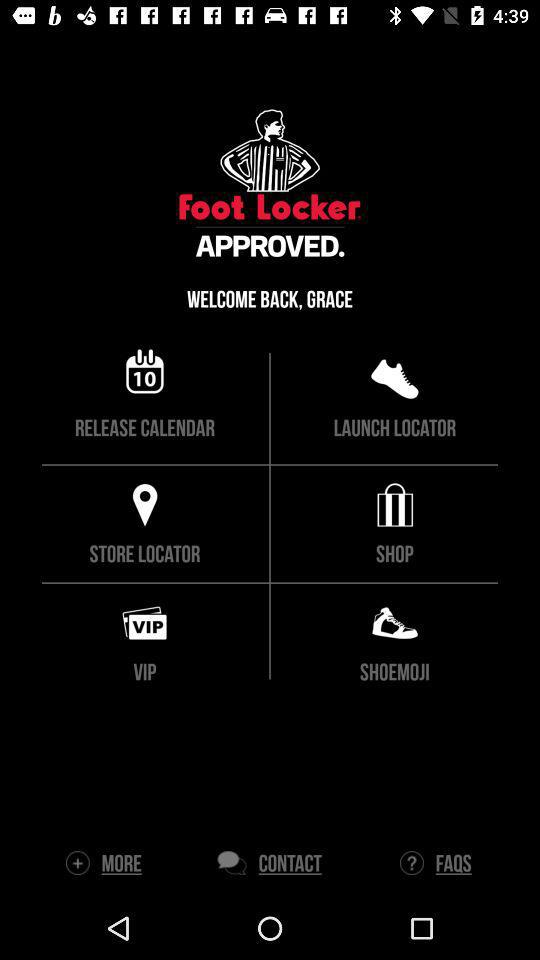What is the application name? The application name is "Foot Locker". 